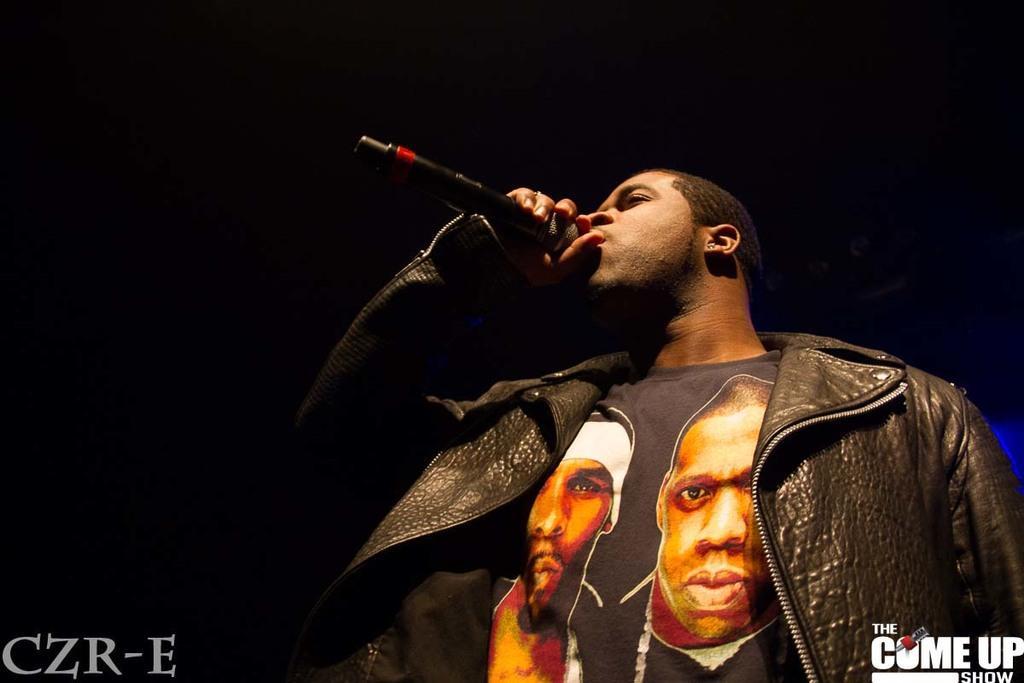In one or two sentences, can you explain what this image depicts? In this image we can see a man holding the mike and standing and the background is in black color. We can also see the text. 